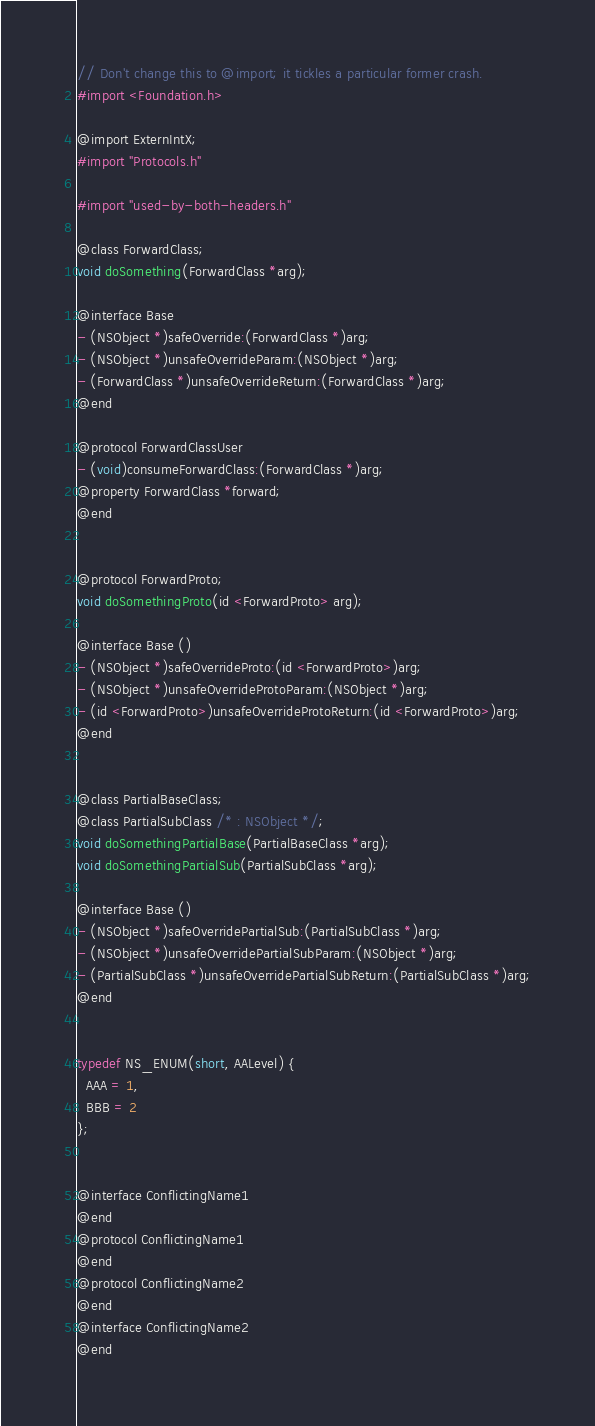<code> <loc_0><loc_0><loc_500><loc_500><_C_>// Don't change this to @import; it tickles a particular former crash.
#import <Foundation.h>

@import ExternIntX;
#import "Protocols.h"

#import "used-by-both-headers.h"

@class ForwardClass;
void doSomething(ForwardClass *arg);

@interface Base
- (NSObject *)safeOverride:(ForwardClass *)arg;
- (NSObject *)unsafeOverrideParam:(NSObject *)arg;
- (ForwardClass *)unsafeOverrideReturn:(ForwardClass *)arg;
@end

@protocol ForwardClassUser
- (void)consumeForwardClass:(ForwardClass *)arg;
@property ForwardClass *forward;
@end


@protocol ForwardProto;
void doSomethingProto(id <ForwardProto> arg);

@interface Base ()
- (NSObject *)safeOverrideProto:(id <ForwardProto>)arg;
- (NSObject *)unsafeOverrideProtoParam:(NSObject *)arg;
- (id <ForwardProto>)unsafeOverrideProtoReturn:(id <ForwardProto>)arg;
@end


@class PartialBaseClass;
@class PartialSubClass /* : NSObject */;
void doSomethingPartialBase(PartialBaseClass *arg);
void doSomethingPartialSub(PartialSubClass *arg);

@interface Base ()
- (NSObject *)safeOverridePartialSub:(PartialSubClass *)arg;
- (NSObject *)unsafeOverridePartialSubParam:(NSObject *)arg;
- (PartialSubClass *)unsafeOverridePartialSubReturn:(PartialSubClass *)arg;
@end


typedef NS_ENUM(short, AALevel) {
  AAA = 1,
  BBB = 2
};


@interface ConflictingName1
@end
@protocol ConflictingName1
@end
@protocol ConflictingName2
@end
@interface ConflictingName2
@end
</code> 